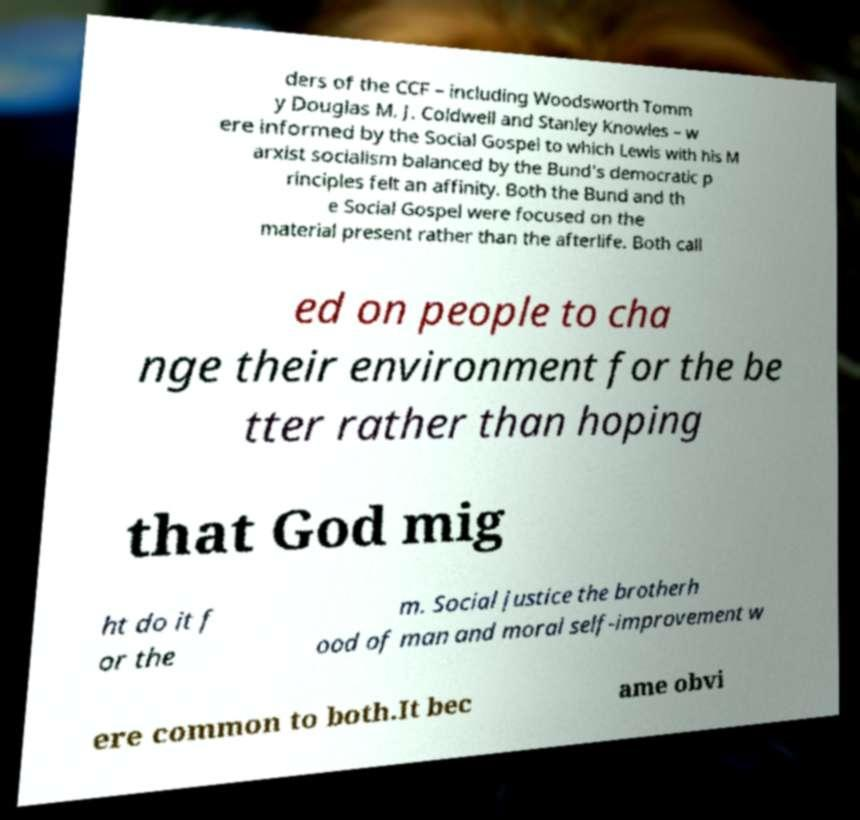For documentation purposes, I need the text within this image transcribed. Could you provide that? ders of the CCF – including Woodsworth Tomm y Douglas M. J. Coldwell and Stanley Knowles – w ere informed by the Social Gospel to which Lewis with his M arxist socialism balanced by the Bund's democratic p rinciples felt an affinity. Both the Bund and th e Social Gospel were focused on the material present rather than the afterlife. Both call ed on people to cha nge their environment for the be tter rather than hoping that God mig ht do it f or the m. Social justice the brotherh ood of man and moral self-improvement w ere common to both.It bec ame obvi 